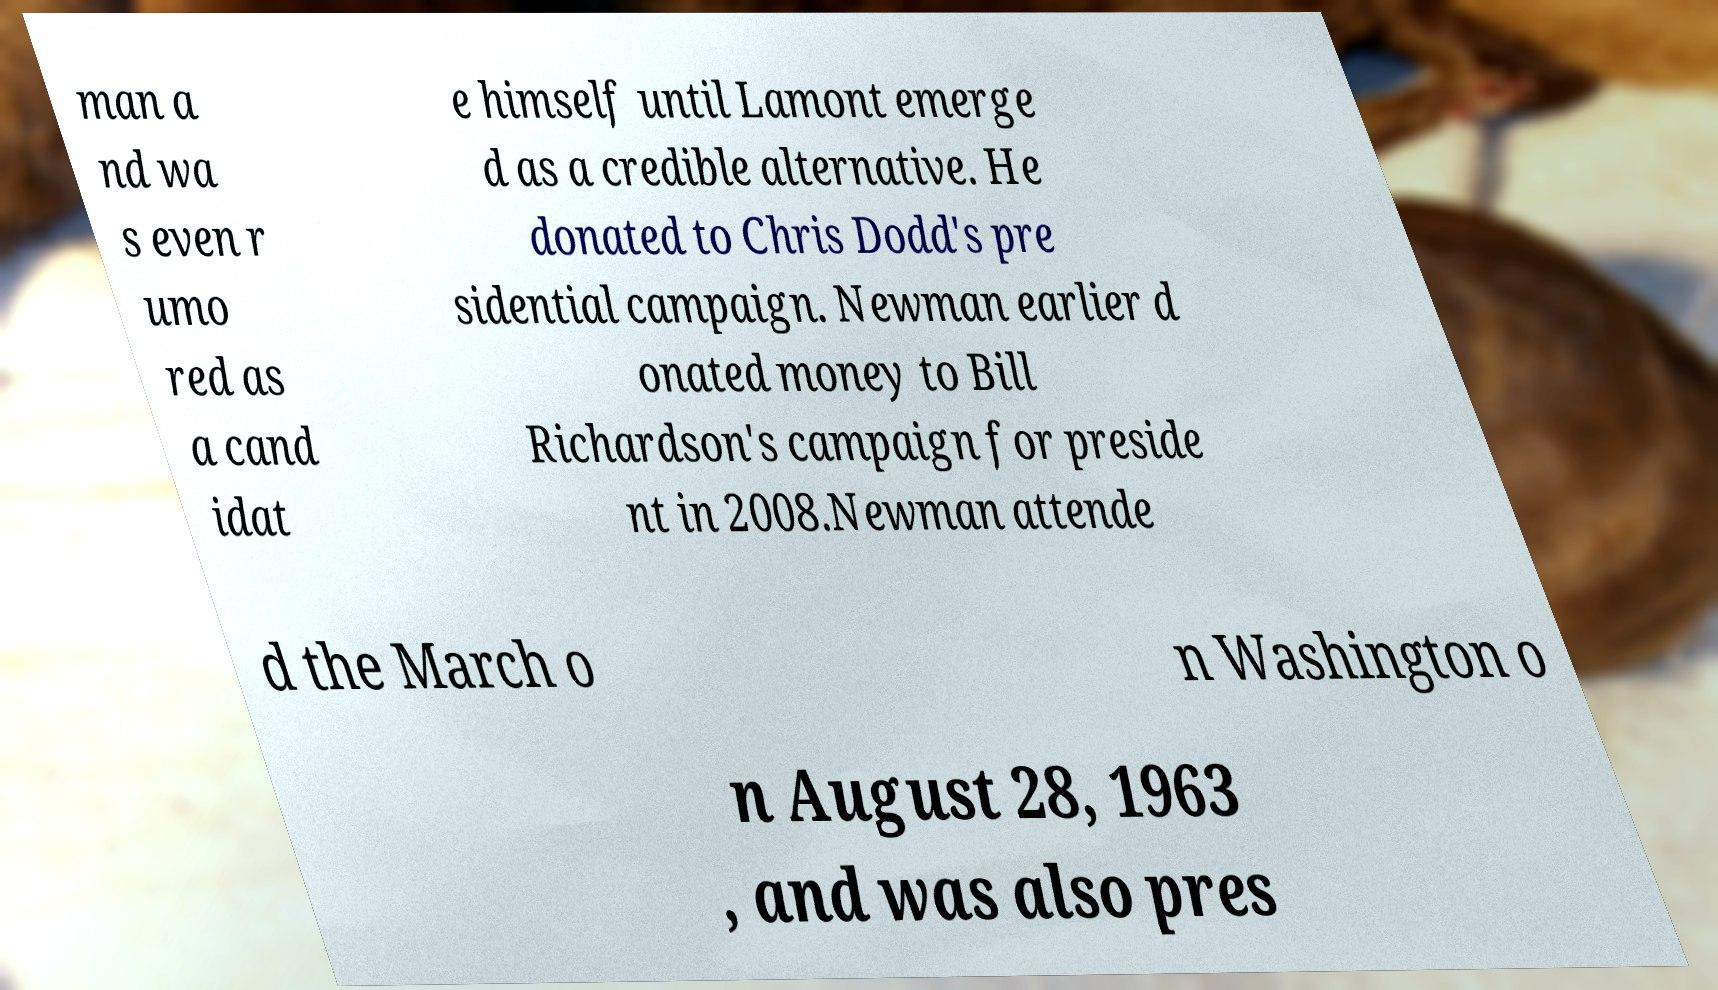Please read and relay the text visible in this image. What does it say? man a nd wa s even r umo red as a cand idat e himself until Lamont emerge d as a credible alternative. He donated to Chris Dodd's pre sidential campaign. Newman earlier d onated money to Bill Richardson's campaign for preside nt in 2008.Newman attende d the March o n Washington o n August 28, 1963 , and was also pres 